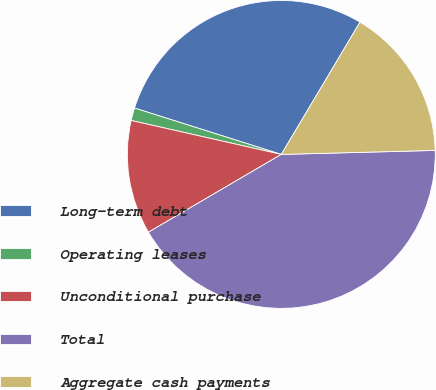Convert chart to OTSL. <chart><loc_0><loc_0><loc_500><loc_500><pie_chart><fcel>Long-term debt<fcel>Operating leases<fcel>Unconditional purchase<fcel>Total<fcel>Aggregate cash payments<nl><fcel>28.67%<fcel>1.33%<fcel>11.97%<fcel>41.98%<fcel>16.04%<nl></chart> 